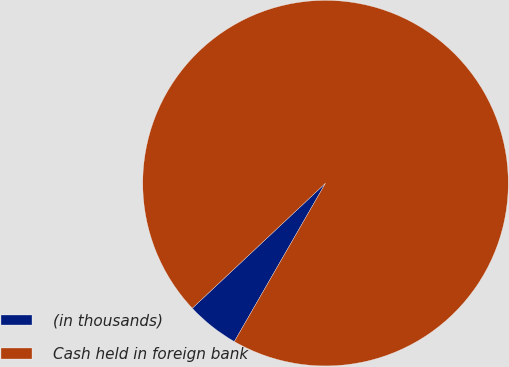<chart> <loc_0><loc_0><loc_500><loc_500><pie_chart><fcel>(in thousands)<fcel>Cash held in foreign bank<nl><fcel>4.69%<fcel>95.31%<nl></chart> 